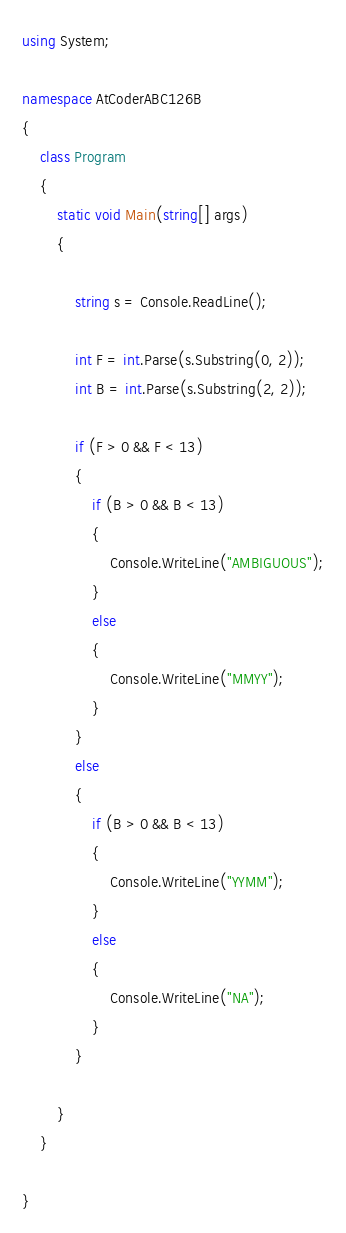Convert code to text. <code><loc_0><loc_0><loc_500><loc_500><_C#_>using System;

namespace AtCoderABC126B
{
    class Program
    {
        static void Main(string[] args)
        {

            string s = Console.ReadLine();

            int F = int.Parse(s.Substring(0, 2));
            int B = int.Parse(s.Substring(2, 2));

            if (F > 0 && F < 13)
            {
                if (B > 0 && B < 13)
                {
                    Console.WriteLine("AMBIGUOUS");
                }
                else
                {
                    Console.WriteLine("MMYY");
                }
            }
            else
            {
                if (B > 0 && B < 13)
                {
                    Console.WriteLine("YYMM");
                }
                else
                {
                    Console.WriteLine("NA");
                }
            }

        }
    }

}
</code> 